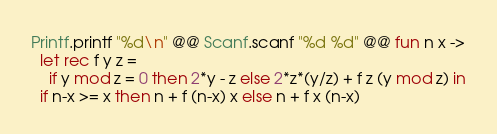<code> <loc_0><loc_0><loc_500><loc_500><_OCaml_>Printf.printf "%d\n" @@ Scanf.scanf "%d %d" @@ fun n x ->
  let rec f y z =
    if y mod z = 0 then 2*y - z else 2*z*(y/z) + f z (y mod z) in
  if n-x >= x then n + f (n-x) x else n + f x (n-x)</code> 